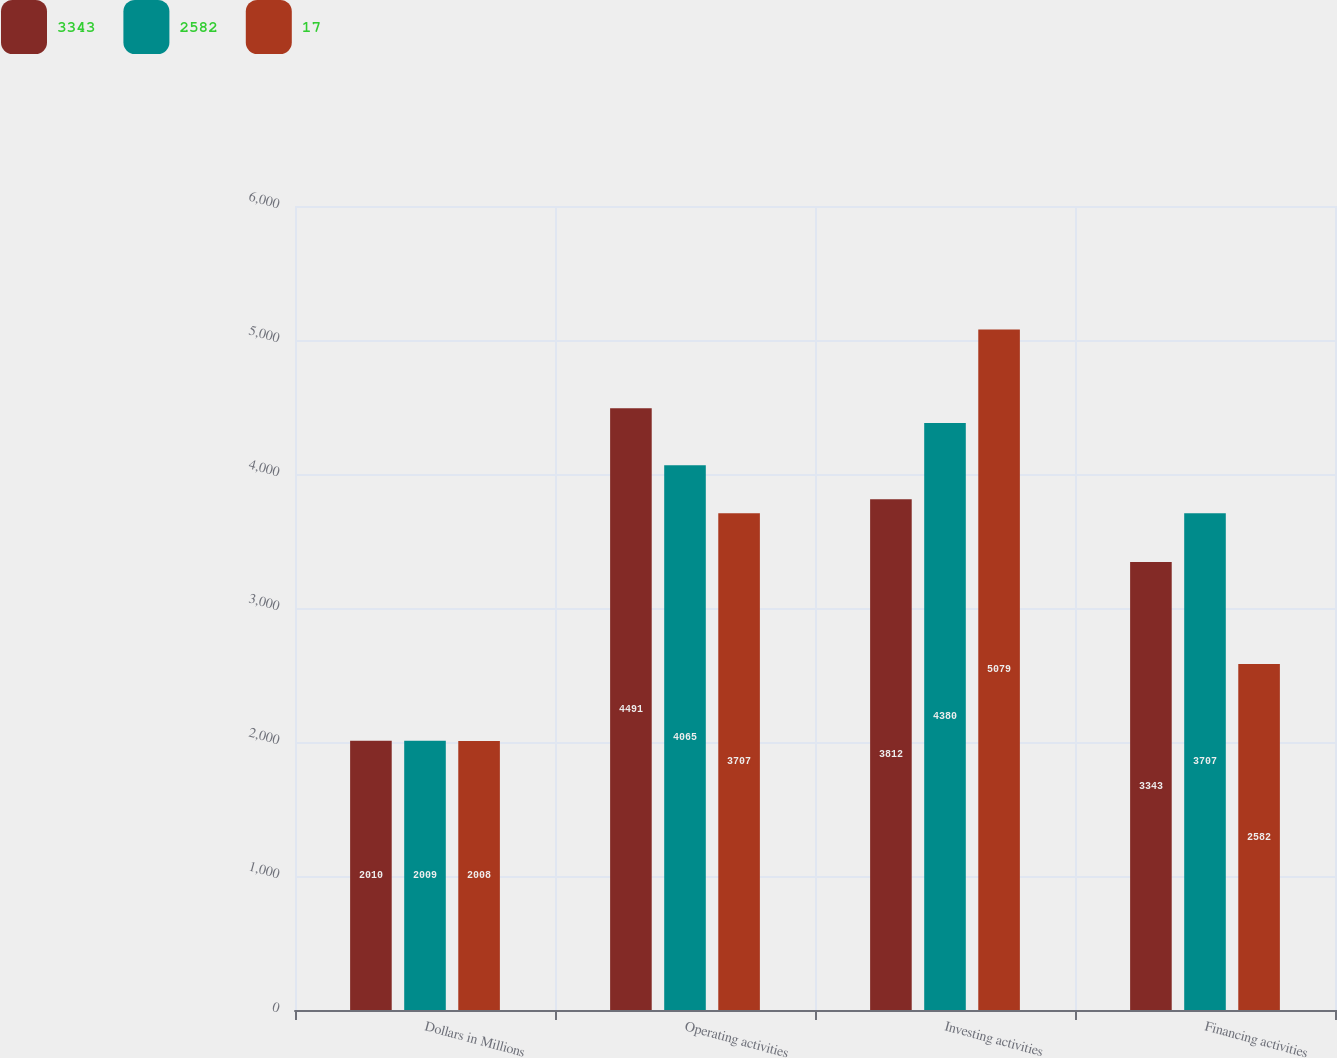Convert chart to OTSL. <chart><loc_0><loc_0><loc_500><loc_500><stacked_bar_chart><ecel><fcel>Dollars in Millions<fcel>Operating activities<fcel>Investing activities<fcel>Financing activities<nl><fcel>3343<fcel>2010<fcel>4491<fcel>3812<fcel>3343<nl><fcel>2582<fcel>2009<fcel>4065<fcel>4380<fcel>3707<nl><fcel>17<fcel>2008<fcel>3707<fcel>5079<fcel>2582<nl></chart> 